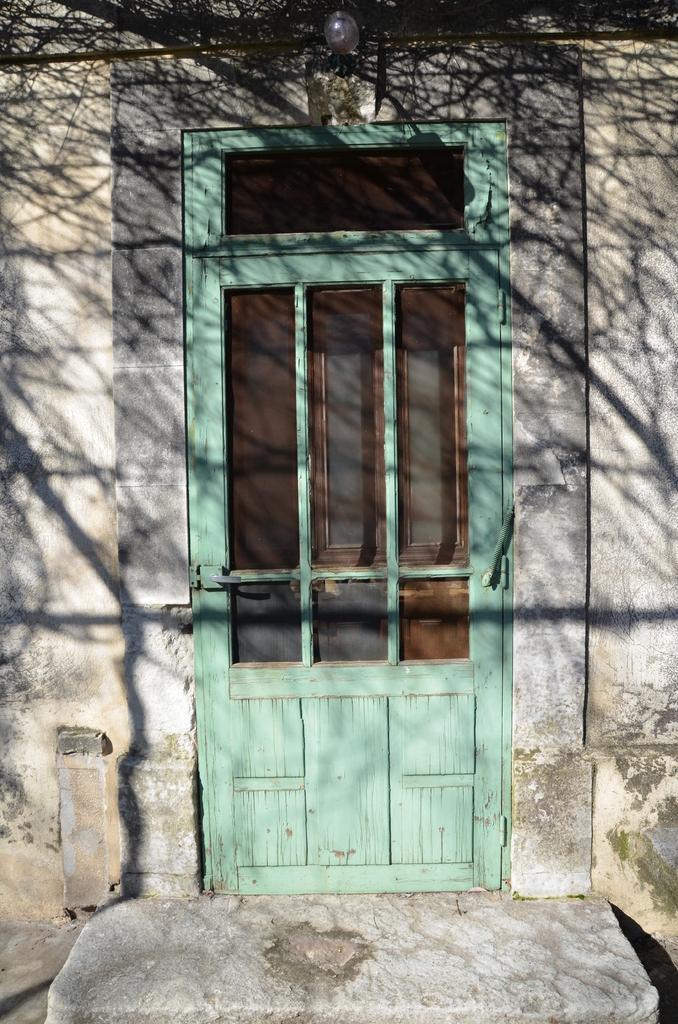In one or two sentences, can you explain what this image depicts? In this image there is a door, there is light, there is wall truncated towards the right of the image, there is wall truncated towards the left of the image. 